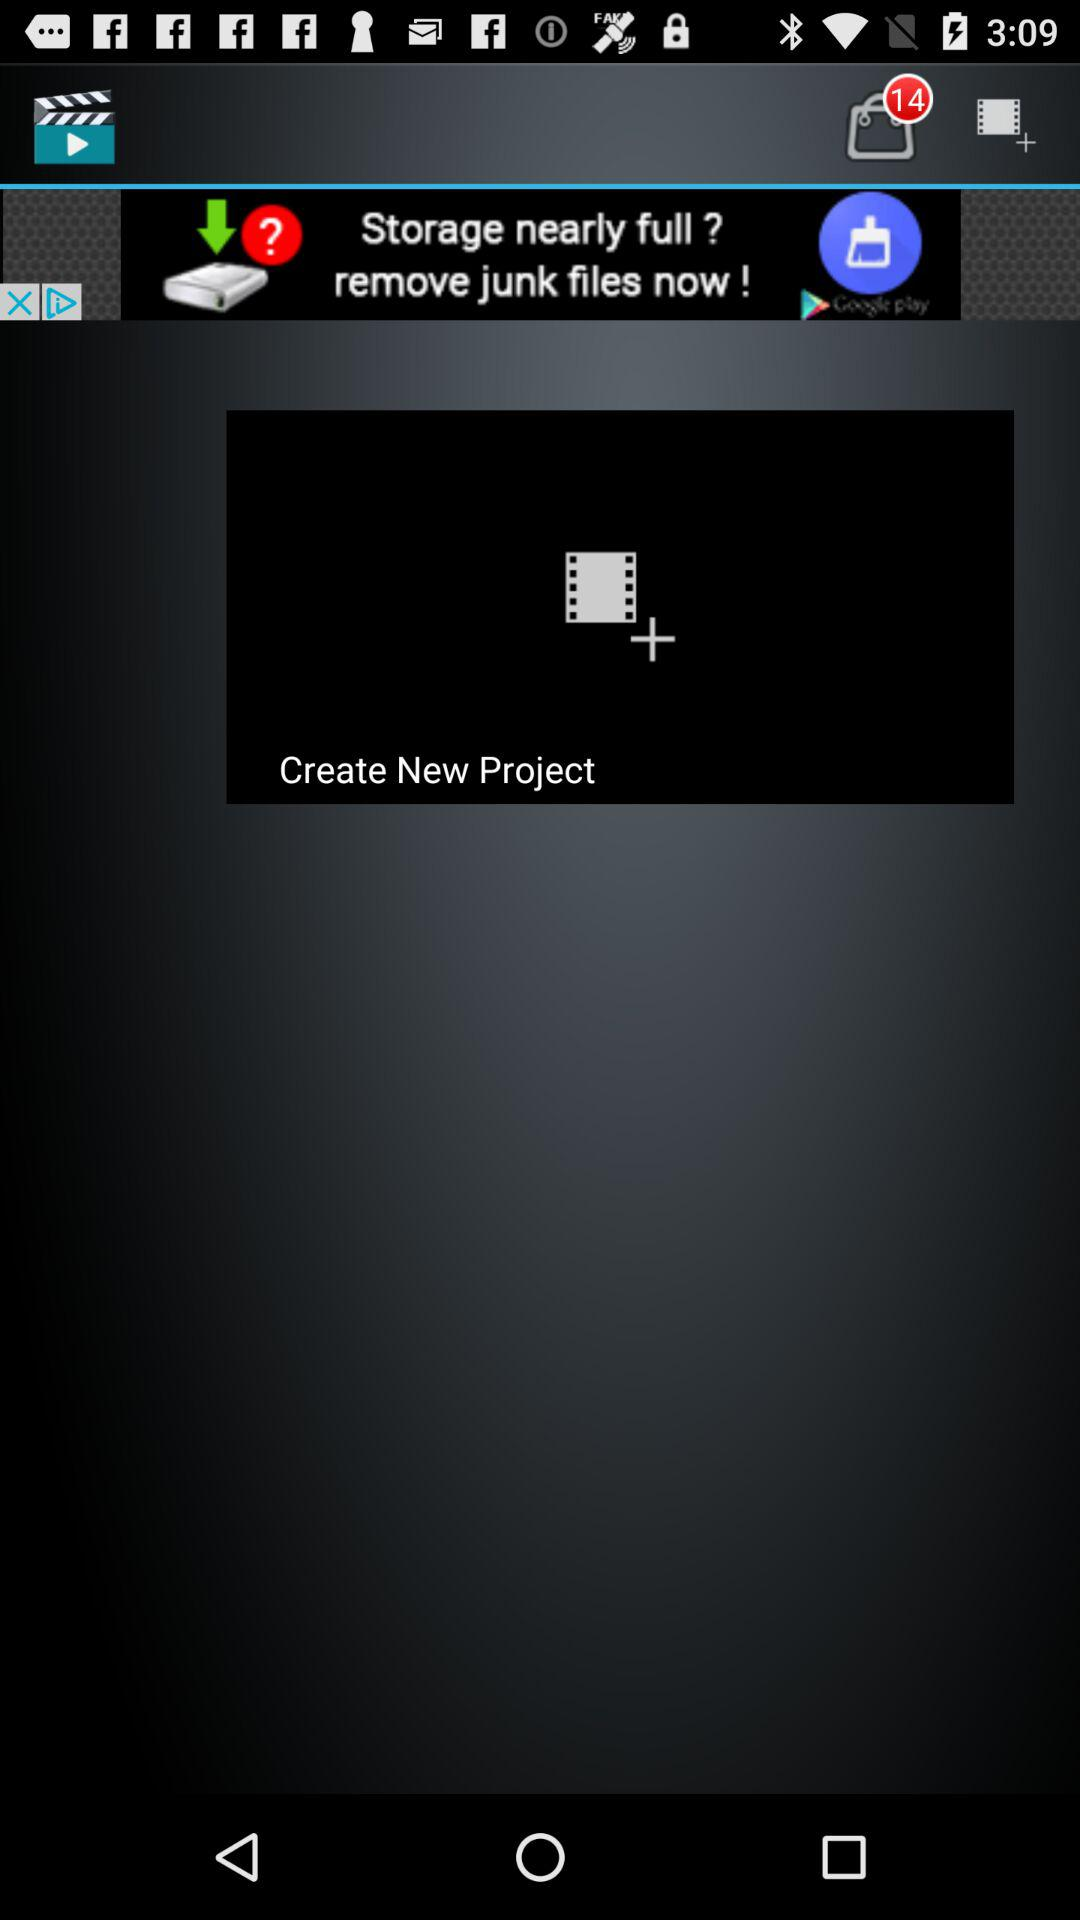How many items are in the cart? There are 14 items in the cart. 